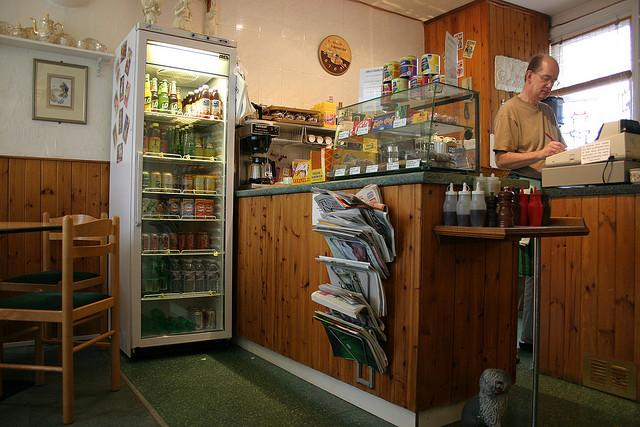What is likely sold here? Please explain your reasoning. newspaper. The small shop sells newspapers that are sitting on a rack by the counter. 